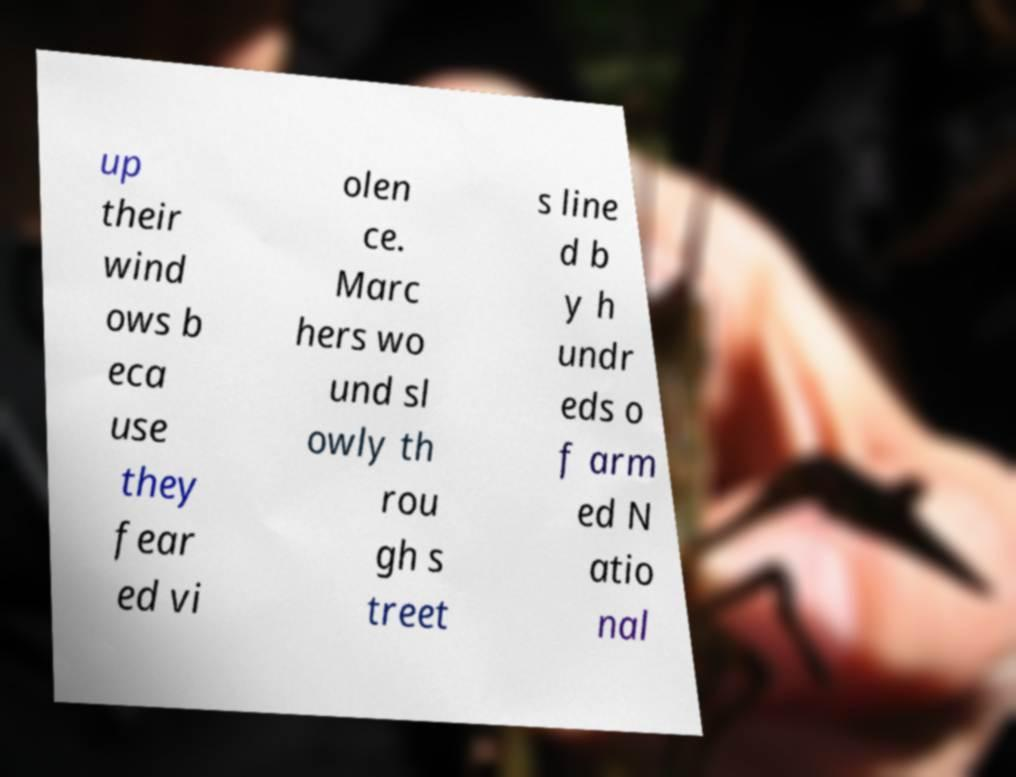Can you read and provide the text displayed in the image?This photo seems to have some interesting text. Can you extract and type it out for me? up their wind ows b eca use they fear ed vi olen ce. Marc hers wo und sl owly th rou gh s treet s line d b y h undr eds o f arm ed N atio nal 